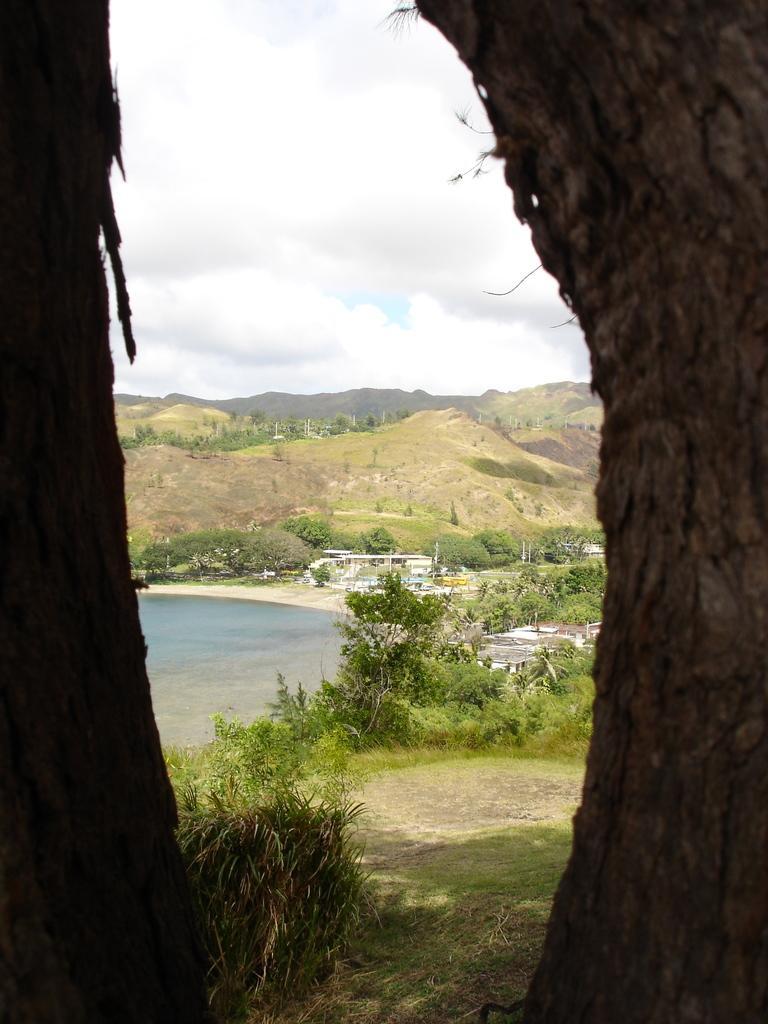Could you give a brief overview of what you see in this image? In this image we can see tree trunks on both sides. In the back we can see plants, trees, water and hills. In the background there is sky with clouds. 